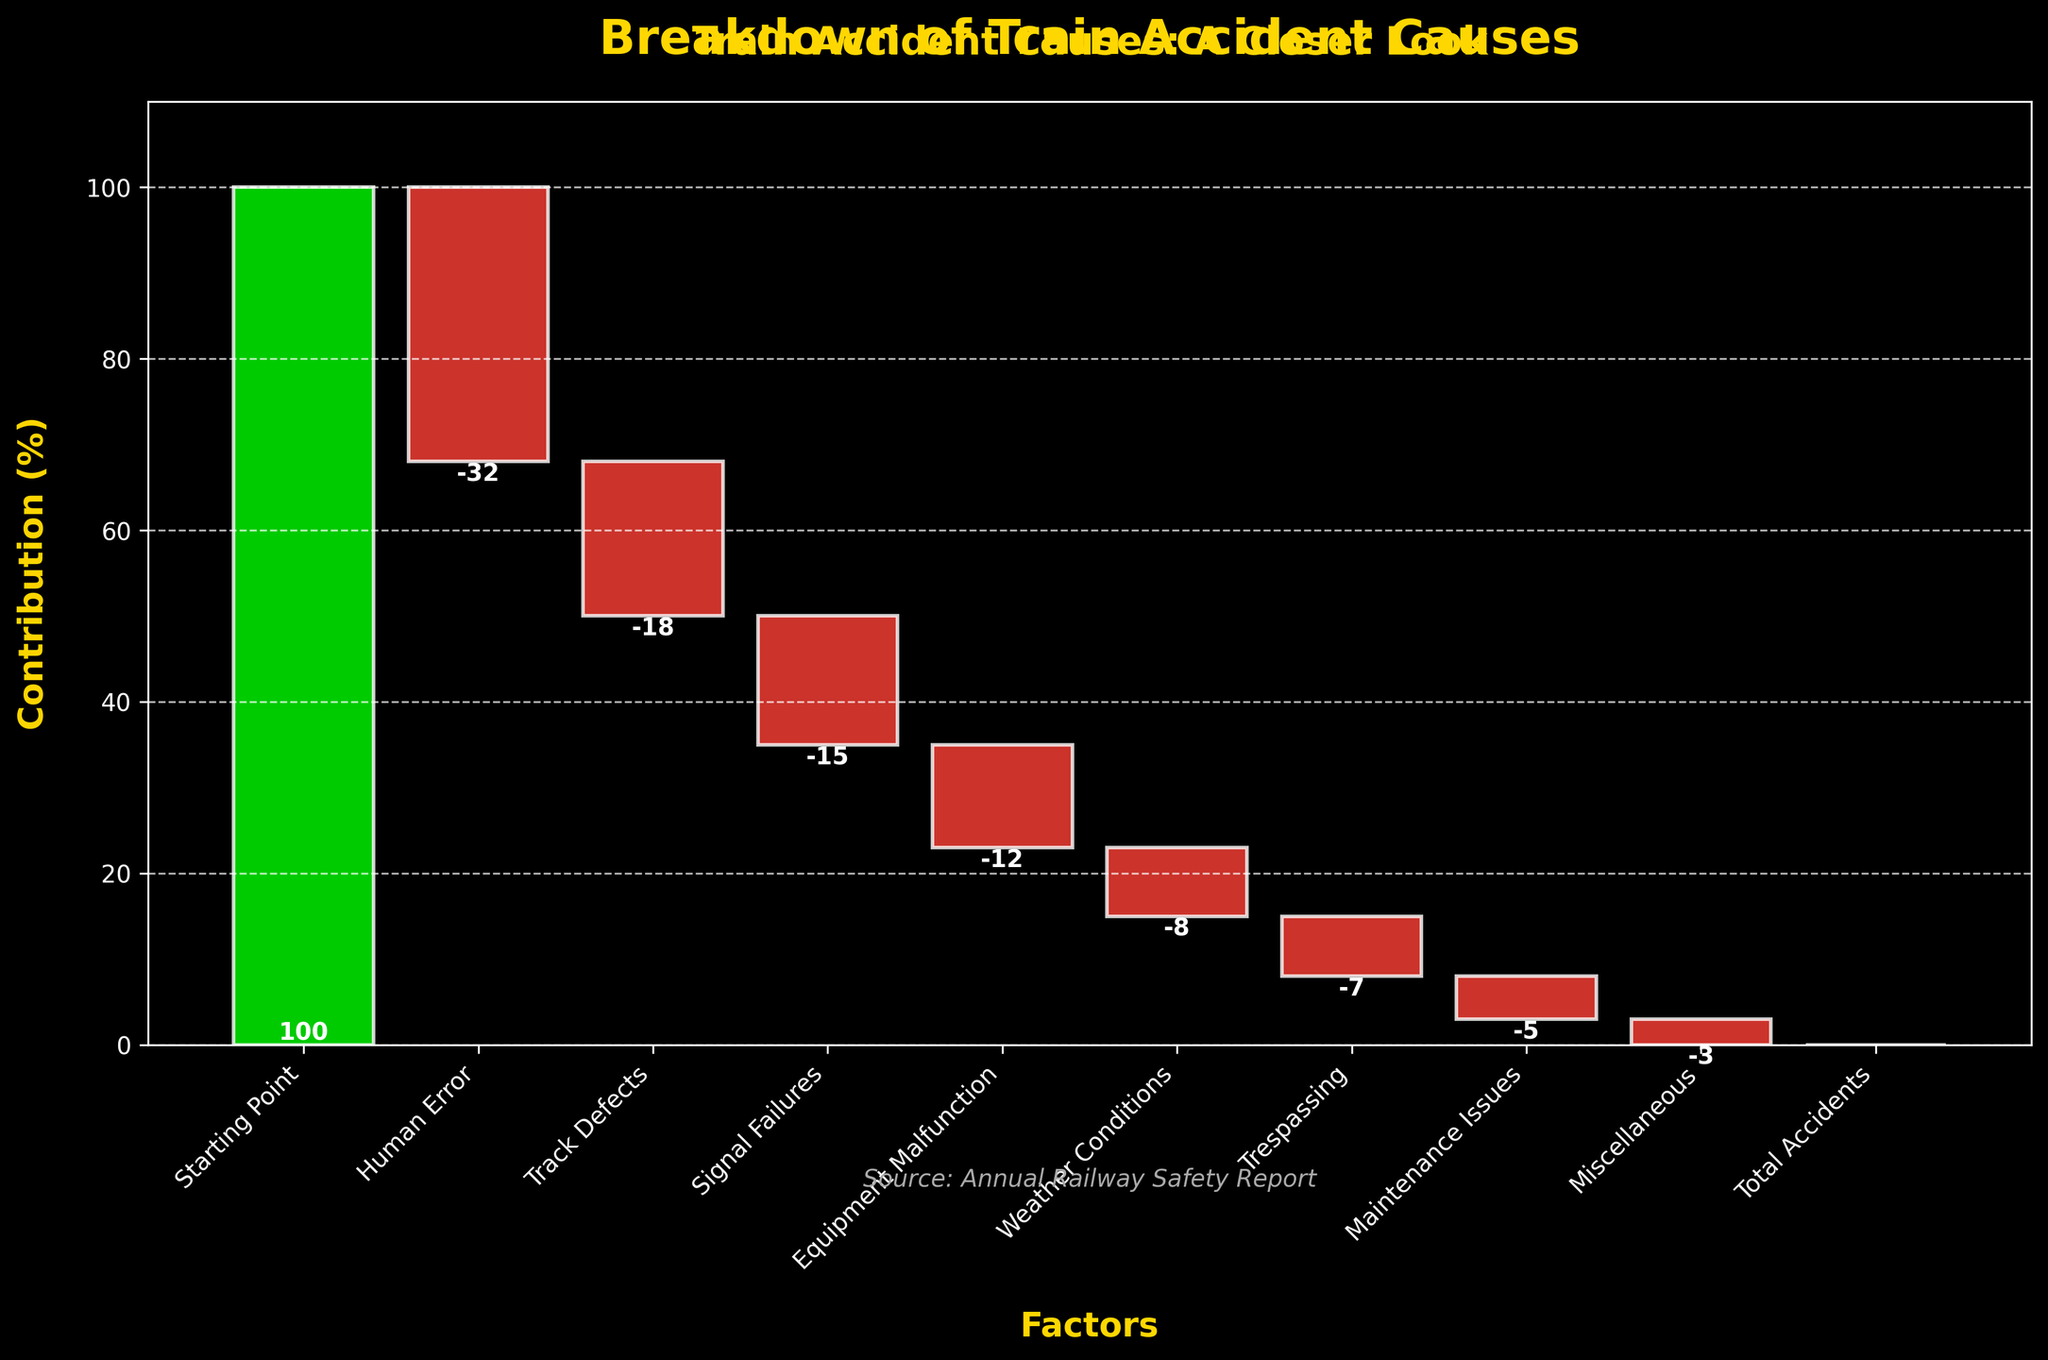What is the title of the chart? The title is located at the top of the chart, in bold and golden color, which indicates the main subject of the visualization.
Answer: Breakdown of Train Accident Causes How many factors contributed to train accidents in the past year? By counting the bars (excluding the Starting Point and Total Accidents), one can determine the number of factors that contributed to train accidents.
Answer: 8 Which factor has the highest negative contribution? By comparing the height of the red bars, which represent negative contributions, the tallest red bar indicates the highest negative contribution.
Answer: Human Error What is the cumulative effect of Track Defects, Signal Failures, and Equipment Malfunctions? Sum the contributions of these factors (-18, -15, and -12) to get the total impact.
Answer: -45 Comparing Human Error and Weather Conditions, which has a greater impact on accidents? Look at the numerical contributions of these factors (Human Error is -32 and Weather Conditions is -8) to determine the difference.
Answer: Human Error What is the contribution of Miscellaneous compared to Maintenance Issues? Check the values for these factors and directly compare them (-3 for Miscellaneous and -5 for Maintenance Issues).
Answer: Miscellaneous has a lesser negative impact than Maintenance Issues What happens to the total number of accidents after accounting for all factors? The cumulative value at the end, indicated by the last column labeled "Total Accidents," shows the net effect of all factors.
Answer: Remains the same (0) Which factors have a contribution between 0 and -10? By examining the heights and positions of the red bars within this range, we can identify the relevant factors.
Answer: Weather Conditions, Trespassing, Maintenance Issues, Miscellaneous Comparing the starting point and the total accidents, what can you infer? The "Starting Point" and "Total Accidents" values are compared, seeing both bars in green, indicating that the initial and final values are the same.
Answer: No change in totals 